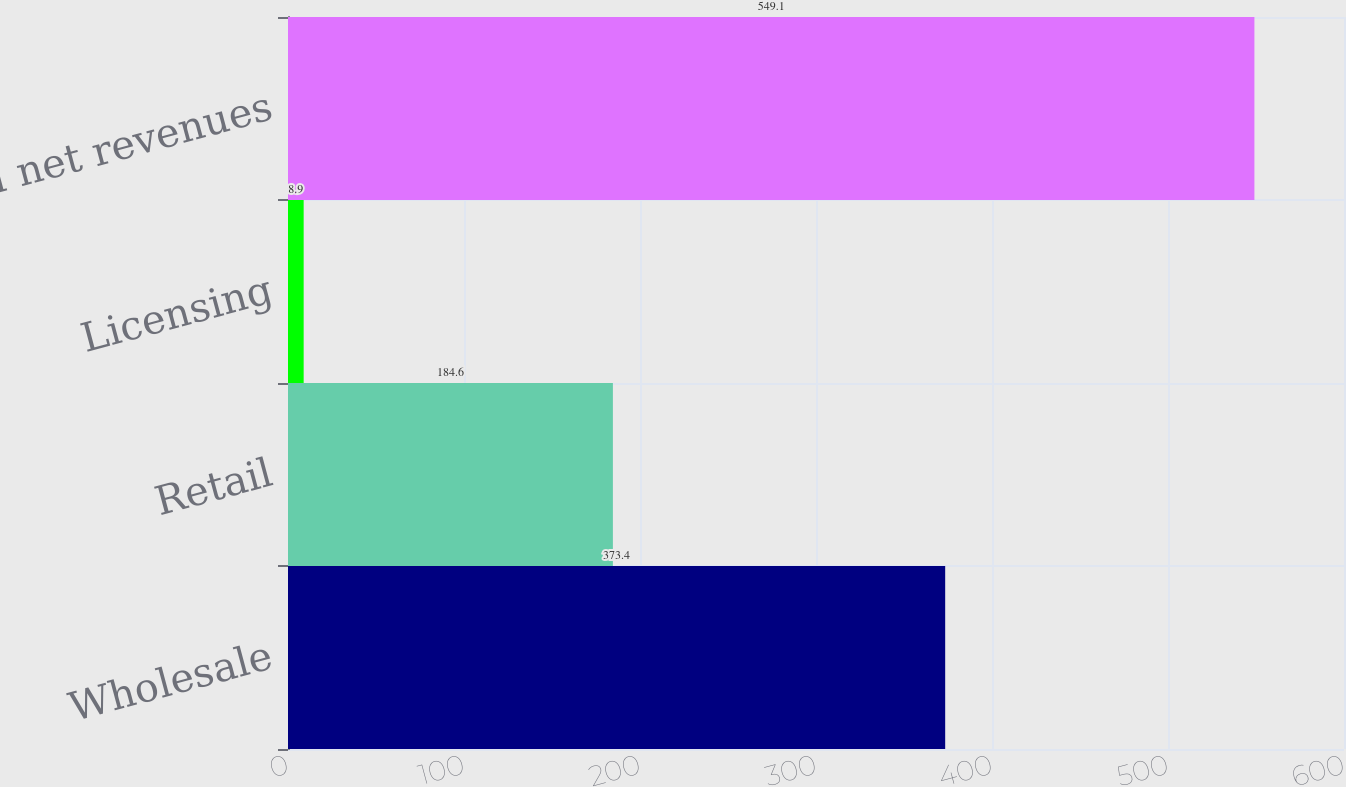Convert chart. <chart><loc_0><loc_0><loc_500><loc_500><bar_chart><fcel>Wholesale<fcel>Retail<fcel>Licensing<fcel>Total net revenues<nl><fcel>373.4<fcel>184.6<fcel>8.9<fcel>549.1<nl></chart> 